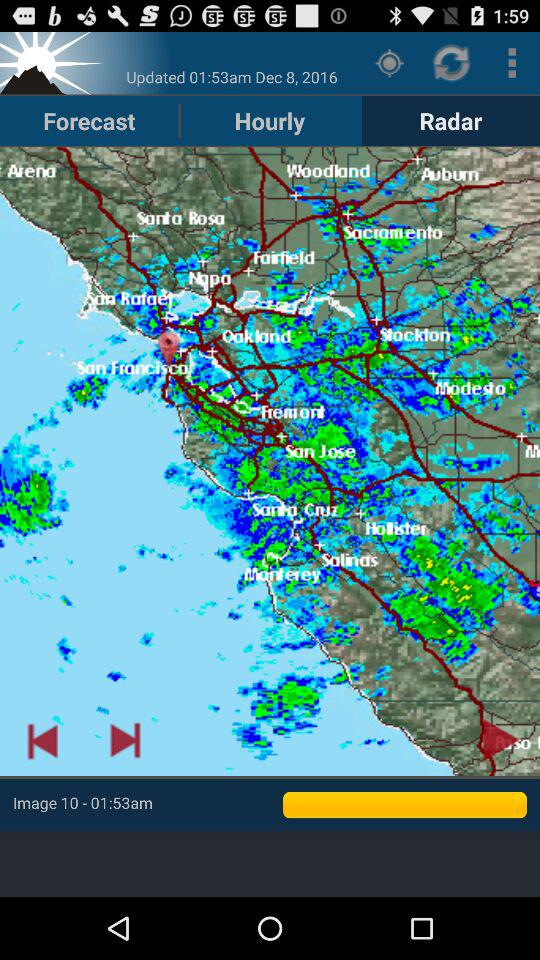What is the weather forecast?
When the provided information is insufficient, respond with <no answer>. <no answer> 